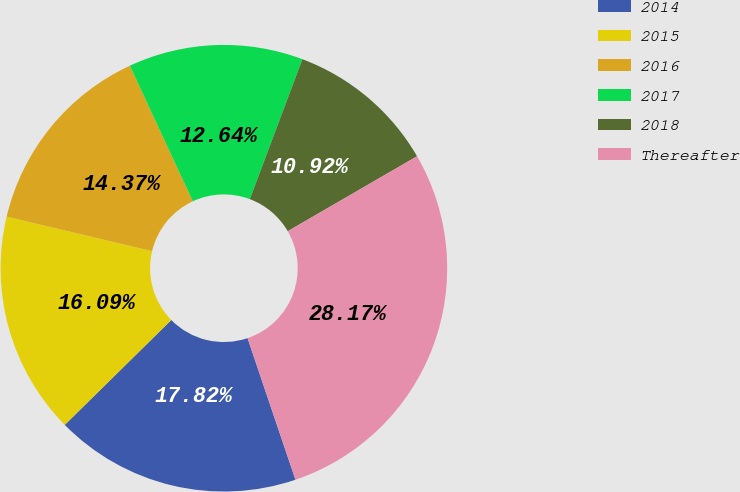Convert chart to OTSL. <chart><loc_0><loc_0><loc_500><loc_500><pie_chart><fcel>2014<fcel>2015<fcel>2016<fcel>2017<fcel>2018<fcel>Thereafter<nl><fcel>17.82%<fcel>16.09%<fcel>14.37%<fcel>12.64%<fcel>10.92%<fcel>28.17%<nl></chart> 